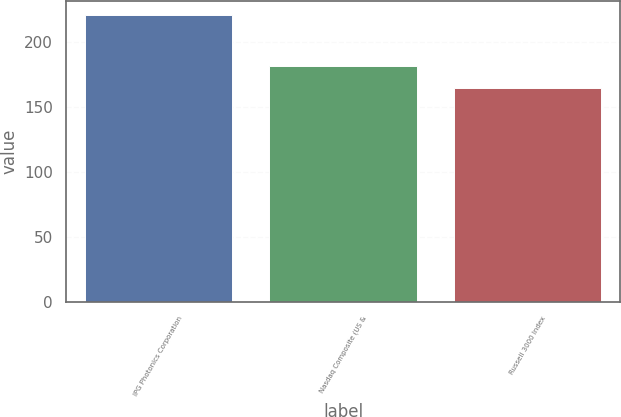Convert chart. <chart><loc_0><loc_0><loc_500><loc_500><bar_chart><fcel>IPG Photonics Corporation<fcel>Nasdaq Composite (US &<fcel>Russell 3000 Index<nl><fcel>221.2<fcel>181.8<fcel>164.85<nl></chart> 